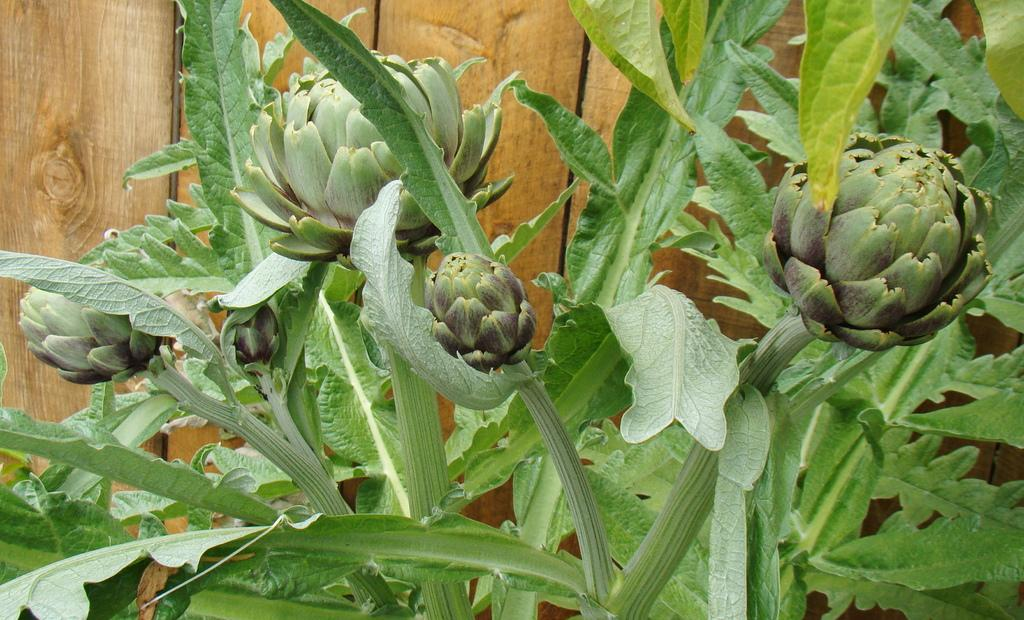What type of flowers are present in the image? There are green flowers in the image. What else can be seen in the image besides the flowers? There are green leaves in the image. Can you describe the wooden object in the background of the image? Unfortunately, the facts provided do not give any details about the wooden object in the background. What nation is represented by the person in the image? There is no person present in the image, so it is not possible to determine which nation they might represent. How many stalks of celery are visible in the image? There is no celery present in the image, so it is not possible to determine the number of stalks visible. 